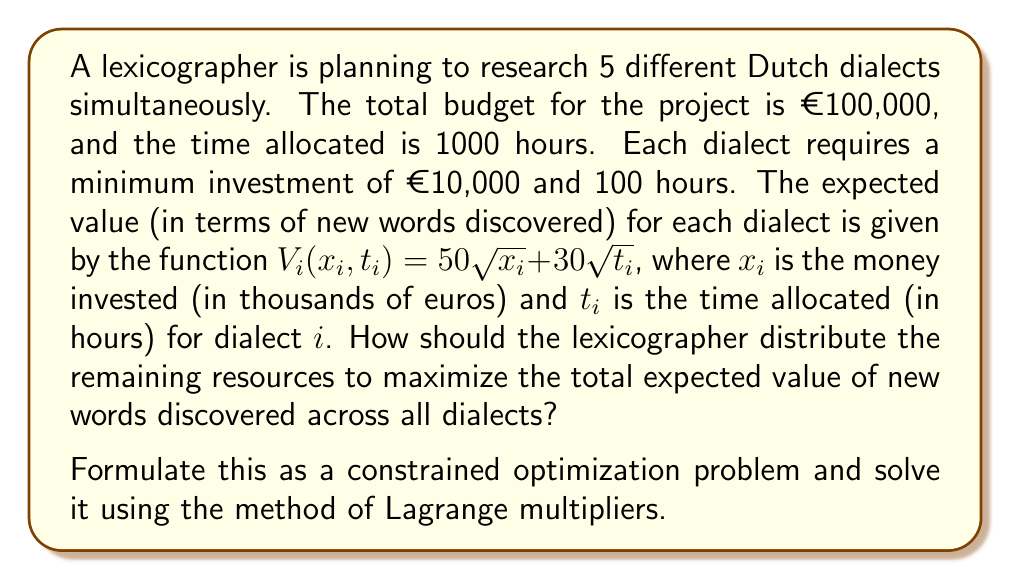Solve this math problem. Let's approach this problem step by step:

1) First, we need to set up our objective function and constraints:

   Objective function: $\max V = \sum_{i=1}^5 (50\sqrt{x_i} + 30\sqrt{t_i})$

   Constraints:
   $$\sum_{i=1}^5 x_i = 100$$
   $$\sum_{i=1}^5 t_i = 1000$$
   $$x_i \geq 10, t_i \geq 100 \text{ for } i = 1,2,3,4,5$$

2) Given the minimum requirements, we can simplify our problem by considering the remaining resources:

   Remaining money: €50,000 (€100,000 - 5 * €10,000)
   Remaining time: 500 hours (1000 - 5 * 100)

   Let's redefine our variables:
   $x_i' = x_i - 10$ and $t_i' = t_i - 100$

3) Our new problem becomes:

   $\max V = \sum_{i=1}^5 (50\sqrt{x_i' + 10} + 30\sqrt{t_i' + 100})$

   Subject to:
   $$\sum_{i=1}^5 x_i' = 50$$
   $$\sum_{i=1}^5 t_i' = 500$$
   $$x_i' \geq 0, t_i' \geq 0 \text{ for } i = 1,2,3,4,5$$

4) We can now form the Lagrangian:

   $L = \sum_{i=1}^5 (50\sqrt{x_i' + 10} + 30\sqrt{t_i' + 100}) - \lambda(\sum_{i=1}^5 x_i' - 50) - \mu(\sum_{i=1}^5 t_i' - 500)$

5) Taking partial derivatives and setting them to zero:

   $\frac{\partial L}{\partial x_i'} = \frac{25}{\sqrt{x_i' + 10}} - \lambda = 0$
   $\frac{\partial L}{\partial t_i'} = \frac{15}{\sqrt{t_i' + 100}} - \mu = 0$

6) From these equations, we can see that all $x_i'$ should be equal, and all $t_i'$ should be equal. Given our constraints:

   $x_i' = 10$ for all $i$
   $t_i' = 100$ for all $i$

7) Translating back to our original variables:

   $x_i = 20$ for all $i$
   $t_i = 200$ for all $i$

Therefore, the optimal distribution is to allocate €20,000 and 200 hours to each dialect.
Answer: The optimal distribution is to allocate €20,000 and 200 hours to each of the 5 dialects. 